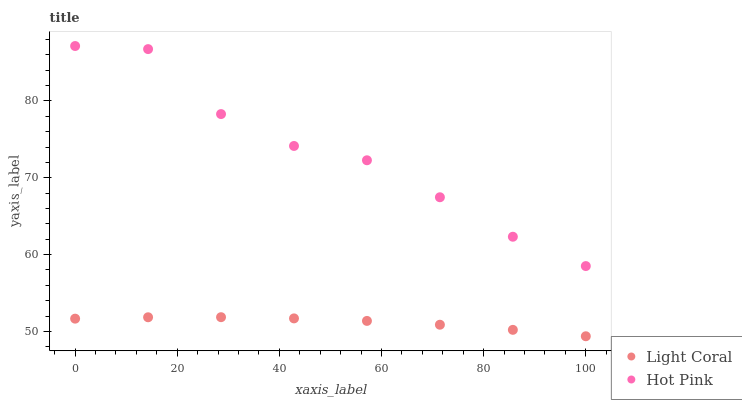Does Light Coral have the minimum area under the curve?
Answer yes or no. Yes. Does Hot Pink have the maximum area under the curve?
Answer yes or no. Yes. Does Hot Pink have the minimum area under the curve?
Answer yes or no. No. Is Light Coral the smoothest?
Answer yes or no. Yes. Is Hot Pink the roughest?
Answer yes or no. Yes. Is Hot Pink the smoothest?
Answer yes or no. No. Does Light Coral have the lowest value?
Answer yes or no. Yes. Does Hot Pink have the lowest value?
Answer yes or no. No. Does Hot Pink have the highest value?
Answer yes or no. Yes. Is Light Coral less than Hot Pink?
Answer yes or no. Yes. Is Hot Pink greater than Light Coral?
Answer yes or no. Yes. Does Light Coral intersect Hot Pink?
Answer yes or no. No. 